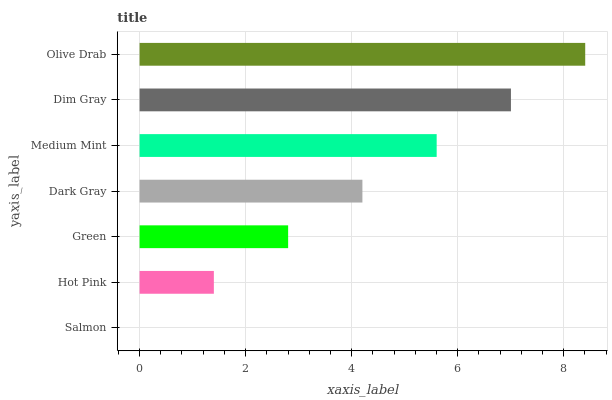Is Salmon the minimum?
Answer yes or no. Yes. Is Olive Drab the maximum?
Answer yes or no. Yes. Is Hot Pink the minimum?
Answer yes or no. No. Is Hot Pink the maximum?
Answer yes or no. No. Is Hot Pink greater than Salmon?
Answer yes or no. Yes. Is Salmon less than Hot Pink?
Answer yes or no. Yes. Is Salmon greater than Hot Pink?
Answer yes or no. No. Is Hot Pink less than Salmon?
Answer yes or no. No. Is Dark Gray the high median?
Answer yes or no. Yes. Is Dark Gray the low median?
Answer yes or no. Yes. Is Green the high median?
Answer yes or no. No. Is Olive Drab the low median?
Answer yes or no. No. 